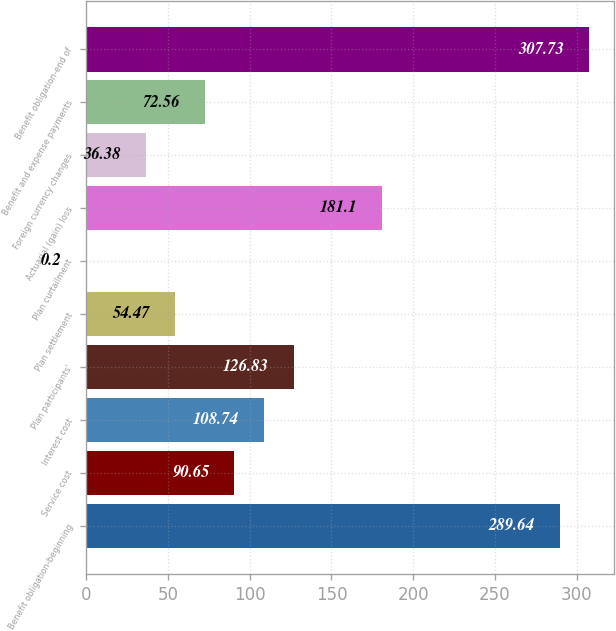Convert chart to OTSL. <chart><loc_0><loc_0><loc_500><loc_500><bar_chart><fcel>Benefit obligation-beginning<fcel>Service cost<fcel>Interest cost<fcel>Plan participants'<fcel>Plan settlement<fcel>Plan curtailment<fcel>Actuarial (gain) loss<fcel>Foreign currency changes<fcel>Benefit and expense payments<fcel>Benefit obligation-end of<nl><fcel>289.64<fcel>90.65<fcel>108.74<fcel>126.83<fcel>54.47<fcel>0.2<fcel>181.1<fcel>36.38<fcel>72.56<fcel>307.73<nl></chart> 